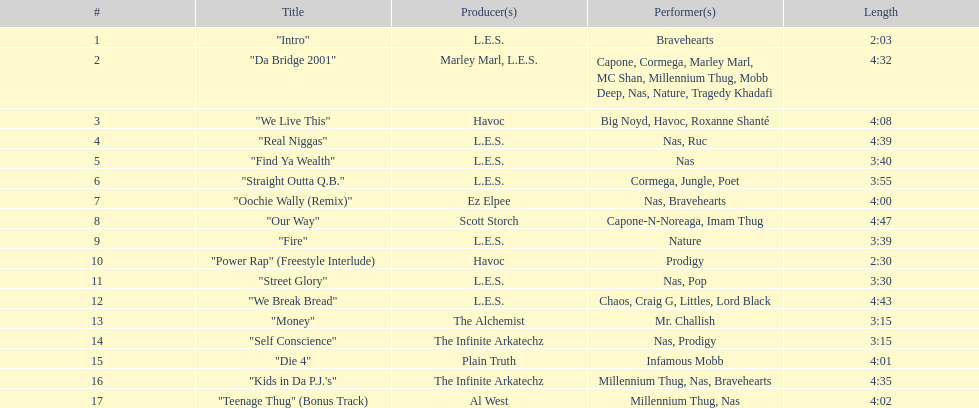Following street glory, which song is mentioned? "We Break Bread". 